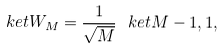Convert formula to latex. <formula><loc_0><loc_0><loc_500><loc_500>\ k e t { W _ { M } } = \frac { 1 } { \sqrt { M } } \ k e t { M - 1 , 1 } ,</formula> 